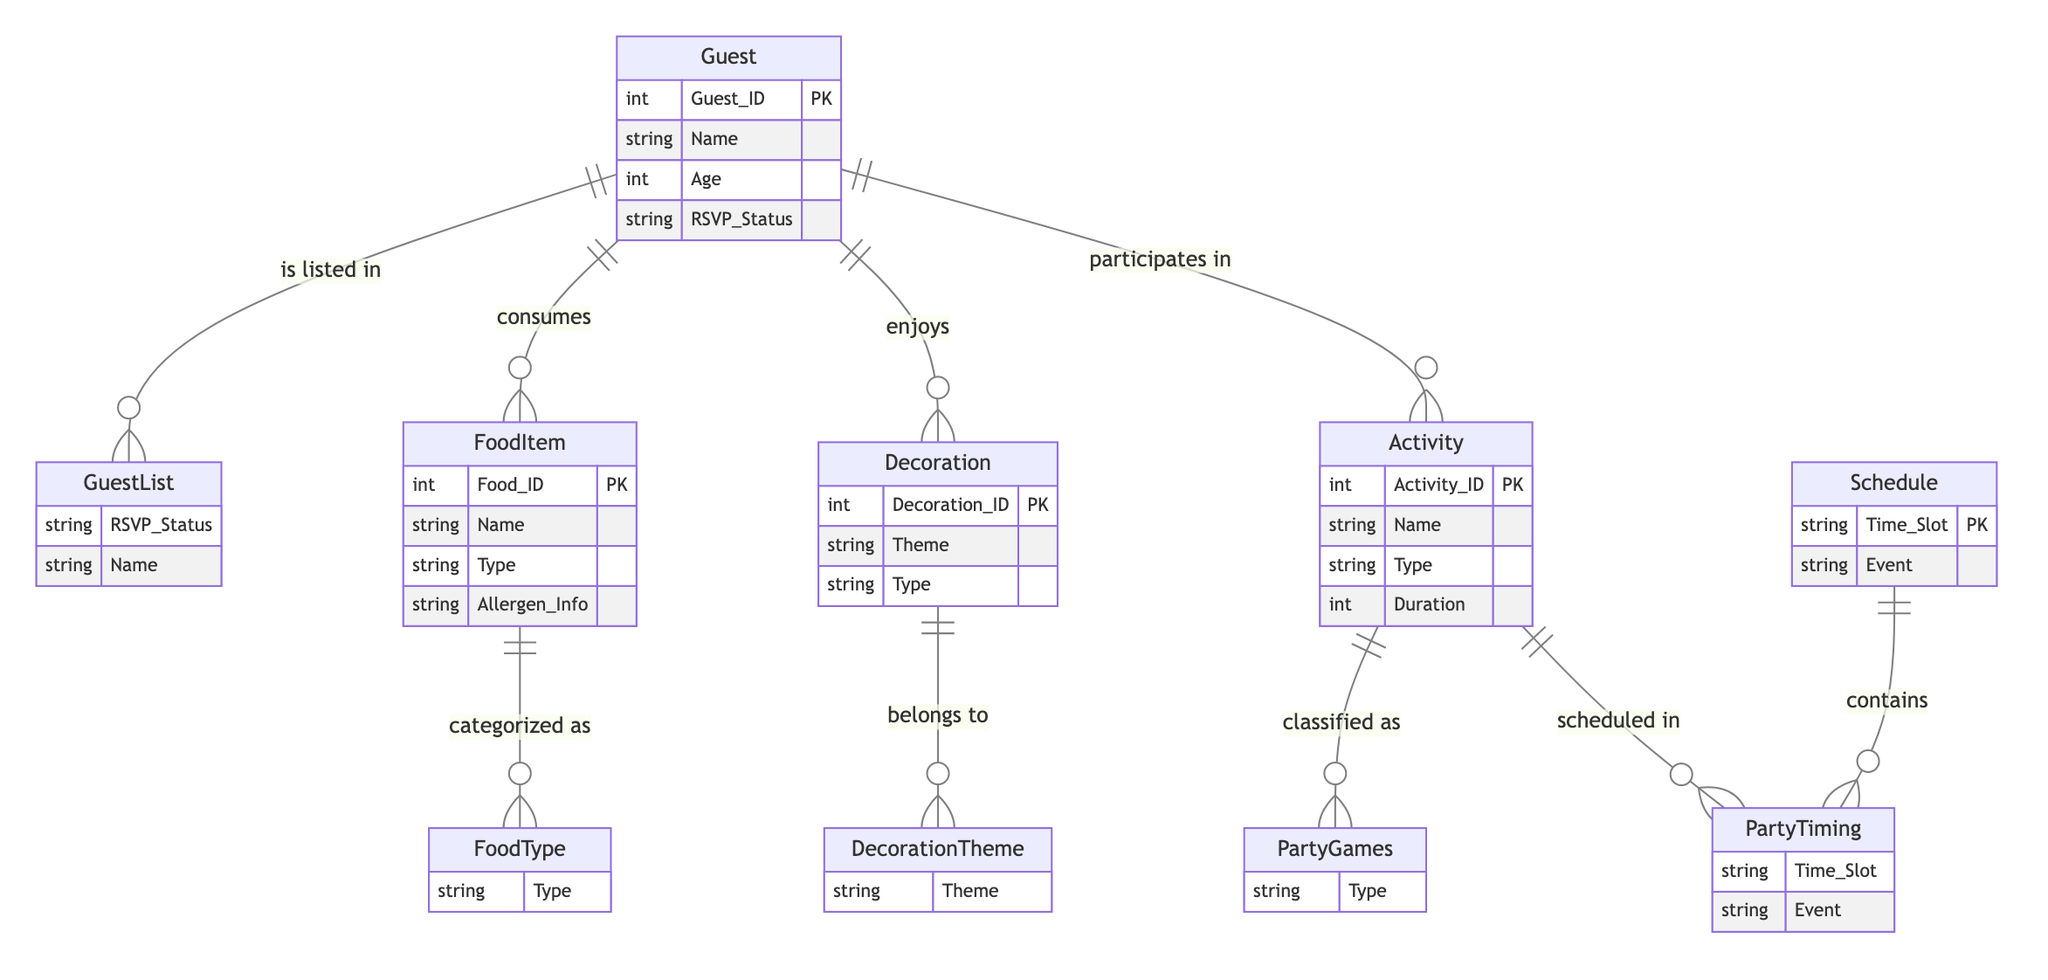What is the primary attribute of the Guest entity? The primary attribute of the Guest entity is Guest_ID, which is marked as a primary key (PK) in the diagram.
Answer: Guest_ID How many different types of food items are there? The connections in the diagram indicate that there is a relationship defining FoodType, which categorizes FoodItem. Since each FoodItem can belong to a different type, we focus on the FoodType entity which signifies the number of unique food categories present.
Answer: Multiple Which entity provides allergen information for food items? The FoodItem entity contains the attribute Allergen_Info, which is specifically designed to provide information about allergens associated with particular food items.
Answer: FoodItem What is the time slot attribute of the Schedule entity used for? The Time_Slot attribute under Schedule indicates specific periods during which scheduled events occur, connecting to Activities through PartyTiming and Activity_Schedule in the diagram.
Answer: Event scheduling How many relationships exist between Guest and Activity? In the diagram, the Guest entity has a relationship with Activity, which shows that guests can participate in multiple activities. The relationship count indicates a one-to-many connection due to the presence of “participates in.”
Answer: One-to-Many What does the FoodItem entity connect with regarding decorations? The diagram indicates a relationship between FoodItem and Decoration, specifically labeled as "FoodItem_Decoration," which implies that certain food items may be associated with or enhance specific decorations at the party.
Answer: Decoration How is the Guest entity linked to food consumption? The relationship mapping "Guest_FoodItem" shows that each guest can consume one or more food items, indicated by the “consumes” relationship that connects these entities in the diagram.
Answer: Consumes What is categorized under FoodType? The FoodType relationship categorizes various food items based on their types, such as snacks, main courses, or desserts, as described in the FoodItem entity's attributes.
Answer: Food types 